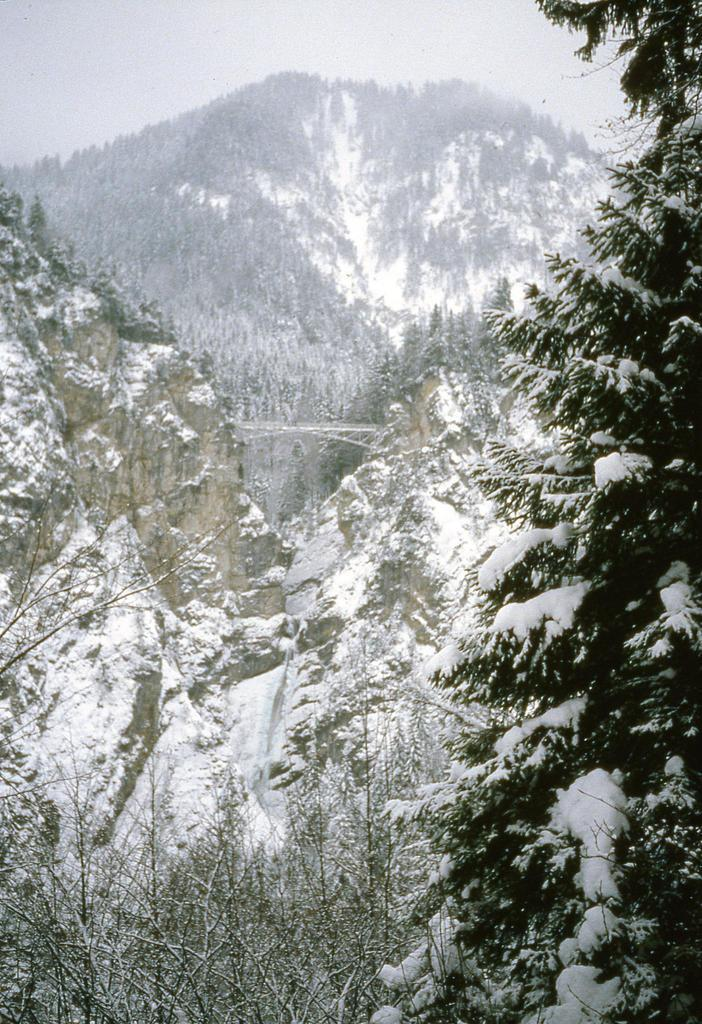What type of natural formation can be seen in the image? There are mountains in the image. What is the condition of the mountains in the image? The mountains are covered with snow. What type of vegetation is on the right side of the image? There is a tree on the right side of the image, and it is covered with snow. What type of plants are visible at the bottom of the image? There are small plants at the bottom of the image. What type of prison can be seen in the image? There is no prison present in the image; it features mountains, a snow-covered tree, and small plants. Can you identify any actors in the image? There are no actors present in the image. 